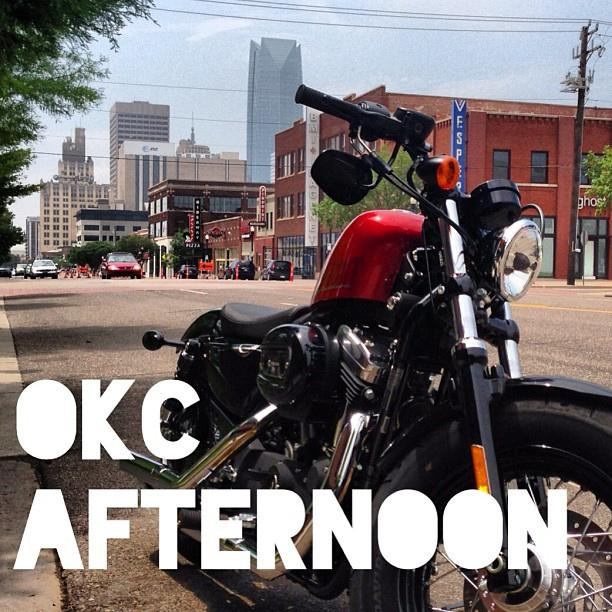What kind of building is the one with the black sign? Please explain your reasoning. restaurant. This is to let people know they can get food 